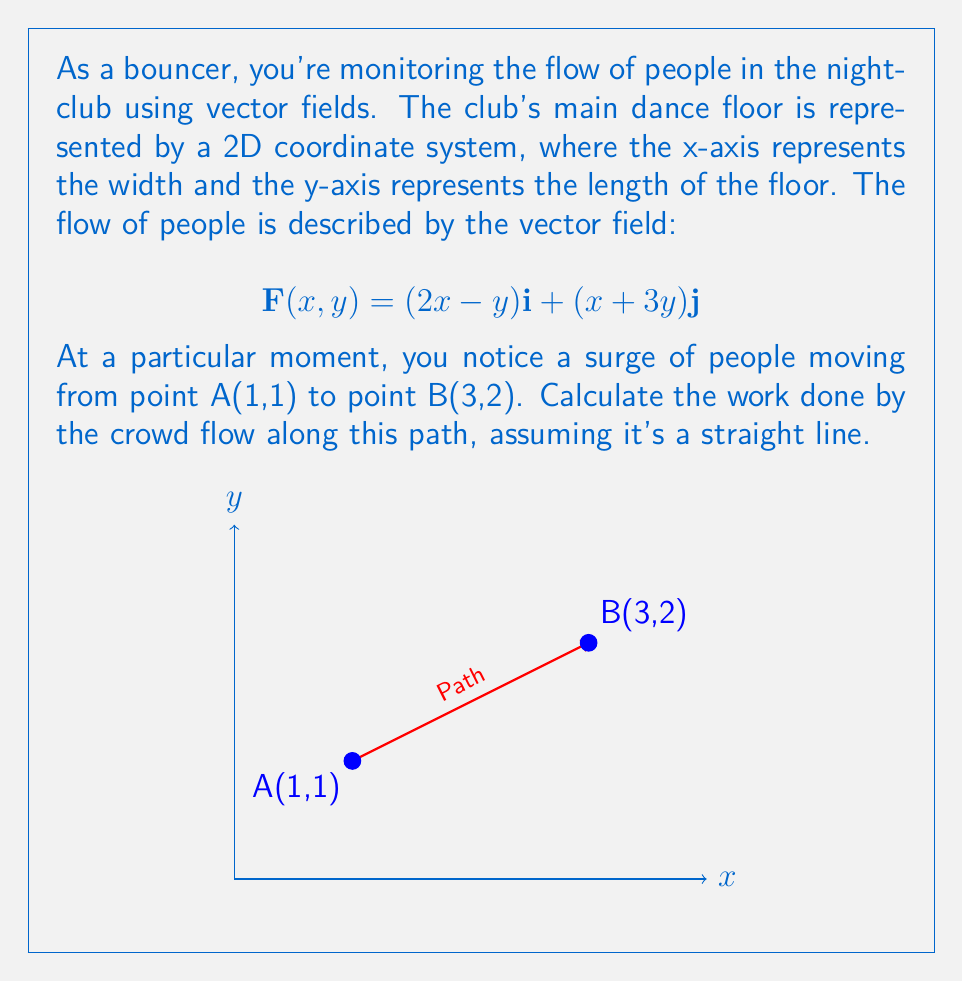Could you help me with this problem? To solve this problem, we'll follow these steps:

1) The work done by a vector field $\mathbf{F}(x,y)$ along a path from point A to point B is given by the line integral:

   $$W = \int_C \mathbf{F} \cdot d\mathbf{r}$$

2) For a straight line path, we can parameterize the path using:
   
   $$x = x_1 + t(x_2 - x_1)$$
   $$y = y_1 + t(y_2 - y_1)$$

   where $(x_1,y_1)$ is the starting point and $(x_2,y_2)$ is the ending point, and $t$ goes from 0 to 1.

3) In this case, $(x_1,y_1) = (1,1)$ and $(x_2,y_2) = (3,2)$. So:

   $$x = 1 + 2t$$
   $$y = 1 + t$$

4) The differential $d\mathbf{r}$ is:

   $$d\mathbf{r} = \frac{dx}{dt}\mathbf{i} + \frac{dy}{dt}\mathbf{j} = 2\mathbf{i} + \mathbf{j}$$

5) Substituting the parameterized equations into the vector field:

   $$\mathbf{F}(t) = (2(1+2t)-(1+t))\mathbf{i} + ((1+2t)+3(1+t))\mathbf{j}$$
   $$= (1+3t)\mathbf{i} + (4+5t)\mathbf{j}$$

6) Now we can compute the dot product $\mathbf{F} \cdot d\mathbf{r}$:

   $$\mathbf{F} \cdot d\mathbf{r} = (1+3t)(2) + (4+5t)(1) = 2+6t+4+5t = 6+11t$$

7) Finally, we integrate from $t=0$ to $t=1$:

   $$W = \int_0^1 (6+11t) dt = [6t + \frac{11}{2}t^2]_0^1 = 6 + \frac{11}{2} = \frac{23}{2}$$

Therefore, the work done by the crowd flow is $\frac{23}{2}$ units.
Answer: $\frac{23}{2}$ units 